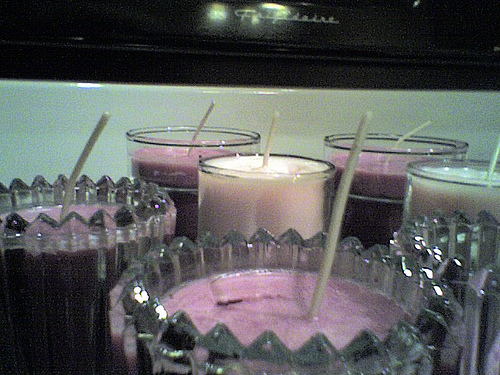<image>
Is there a candle next to the wick? No. The candle is not positioned next to the wick. They are located in different areas of the scene. 